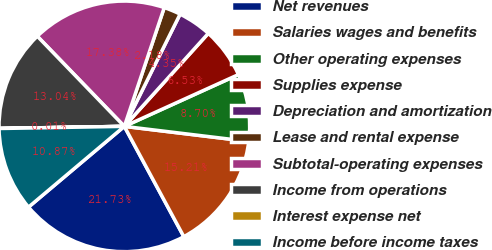Convert chart. <chart><loc_0><loc_0><loc_500><loc_500><pie_chart><fcel>Net revenues<fcel>Salaries wages and benefits<fcel>Other operating expenses<fcel>Supplies expense<fcel>Depreciation and amortization<fcel>Lease and rental expense<fcel>Subtotal-operating expenses<fcel>Income from operations<fcel>Interest expense net<fcel>Income before income taxes<nl><fcel>21.73%<fcel>15.21%<fcel>8.7%<fcel>6.53%<fcel>4.35%<fcel>2.18%<fcel>17.38%<fcel>13.04%<fcel>0.01%<fcel>10.87%<nl></chart> 